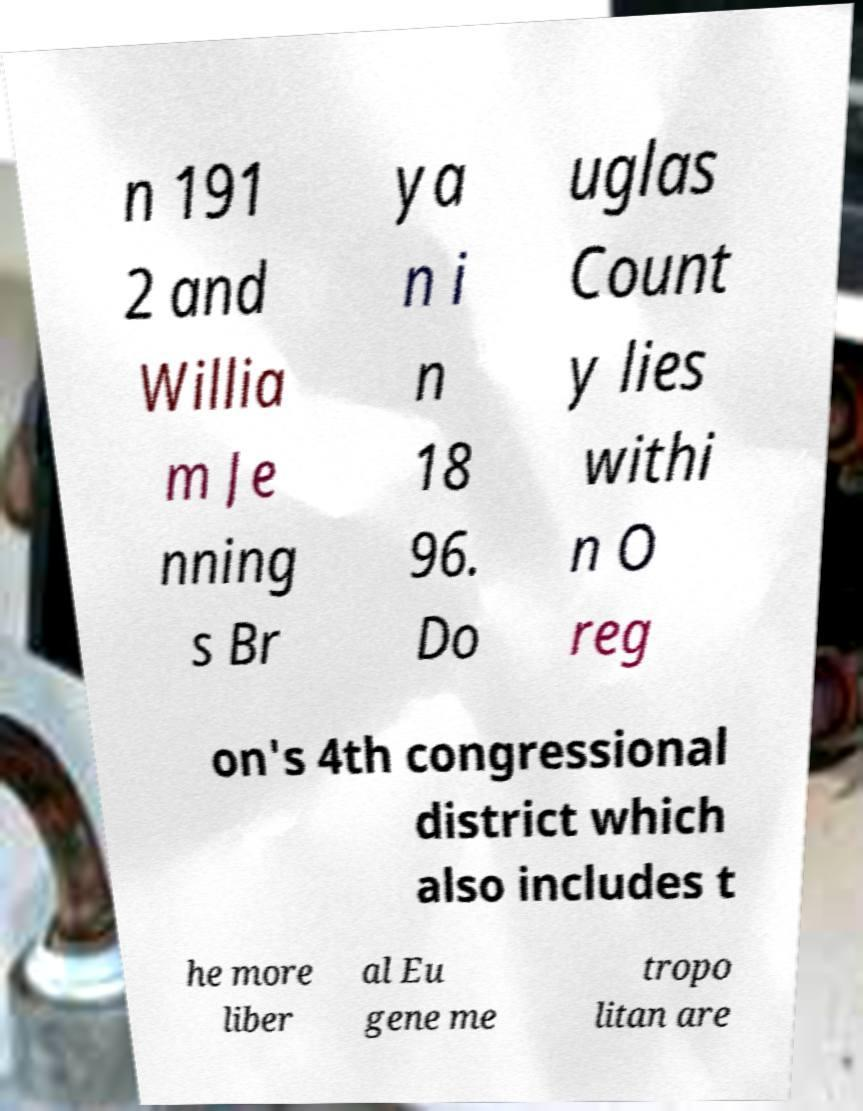Could you extract and type out the text from this image? n 191 2 and Willia m Je nning s Br ya n i n 18 96. Do uglas Count y lies withi n O reg on's 4th congressional district which also includes t he more liber al Eu gene me tropo litan are 